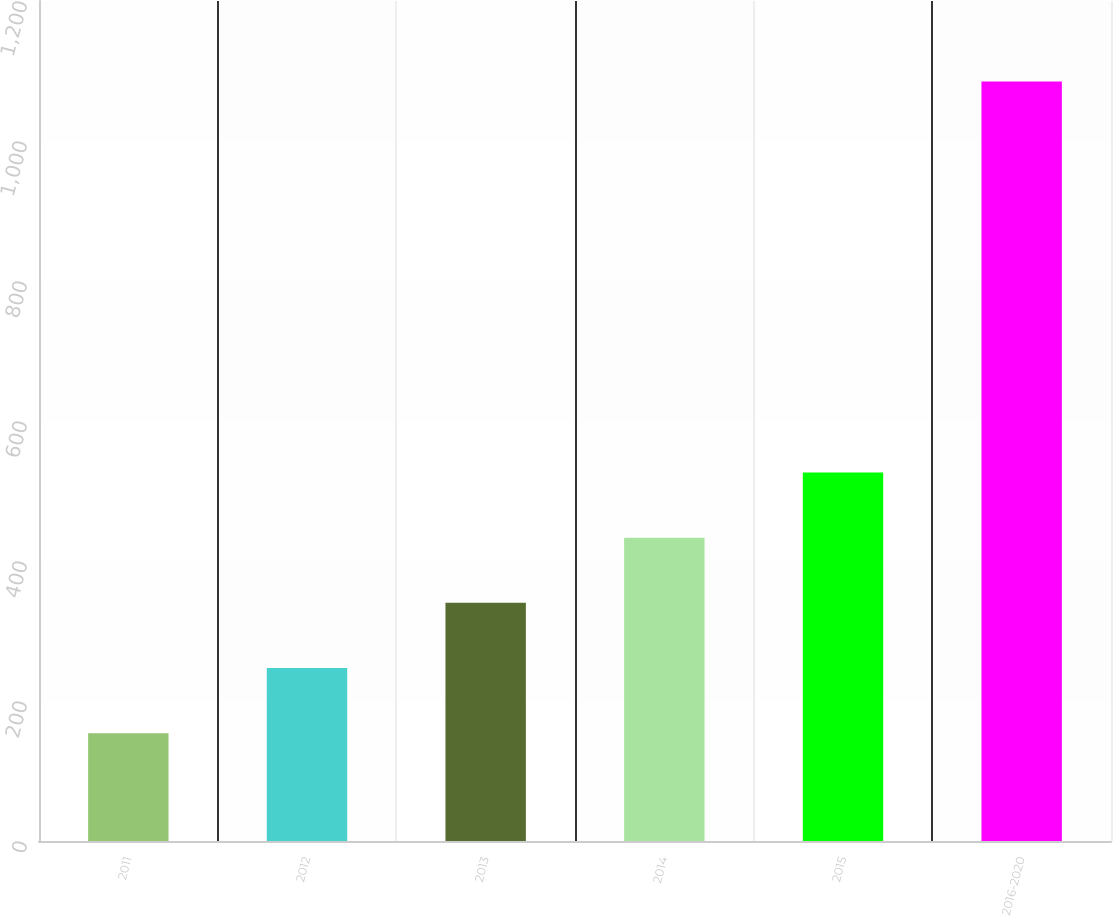Convert chart. <chart><loc_0><loc_0><loc_500><loc_500><bar_chart><fcel>2011<fcel>2012<fcel>2013<fcel>2014<fcel>2015<fcel>2016-2020<nl><fcel>154<fcel>247.1<fcel>340.2<fcel>433.3<fcel>526.4<fcel>1085<nl></chart> 